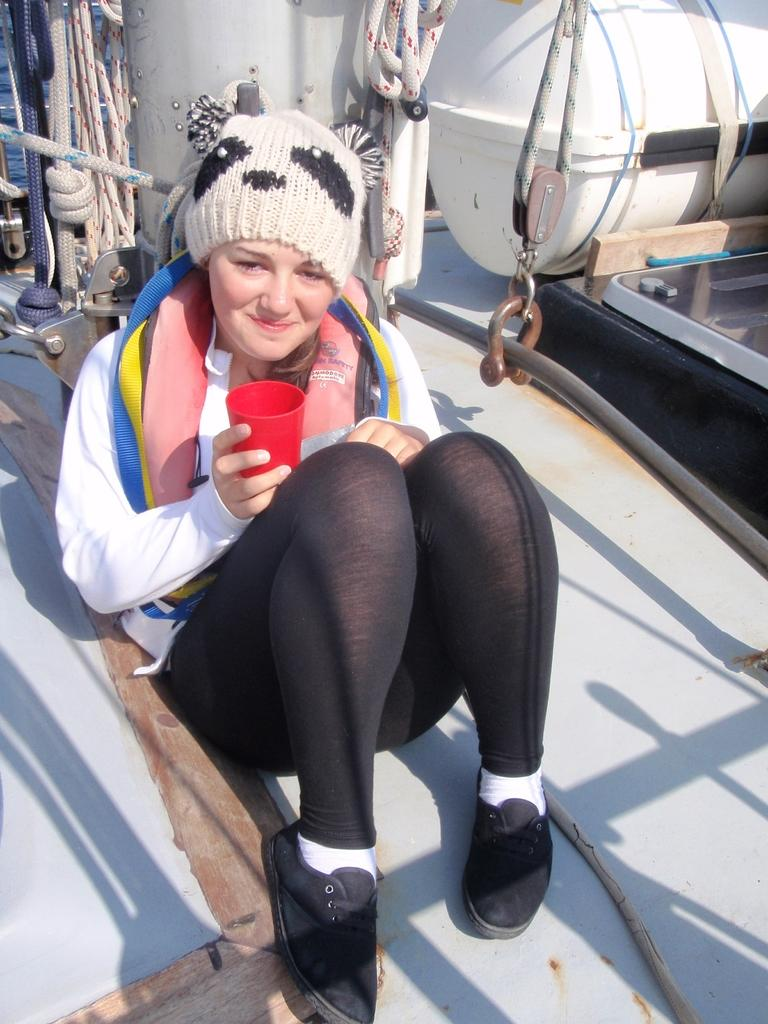Who is the main subject in the image? There is a woman in the image. What is the woman doing in the image? The woman is sitting. What is the woman wearing in the image? The woman is wearing a white coat and black trousers. What is the woman holding in the image? The woman is holding a red glass in her hands. What type of robin can be seen singing on the woman's shoulder in the image? There is no robin present in the image, and the woman is not depicted as having a bird on her shoulder. 